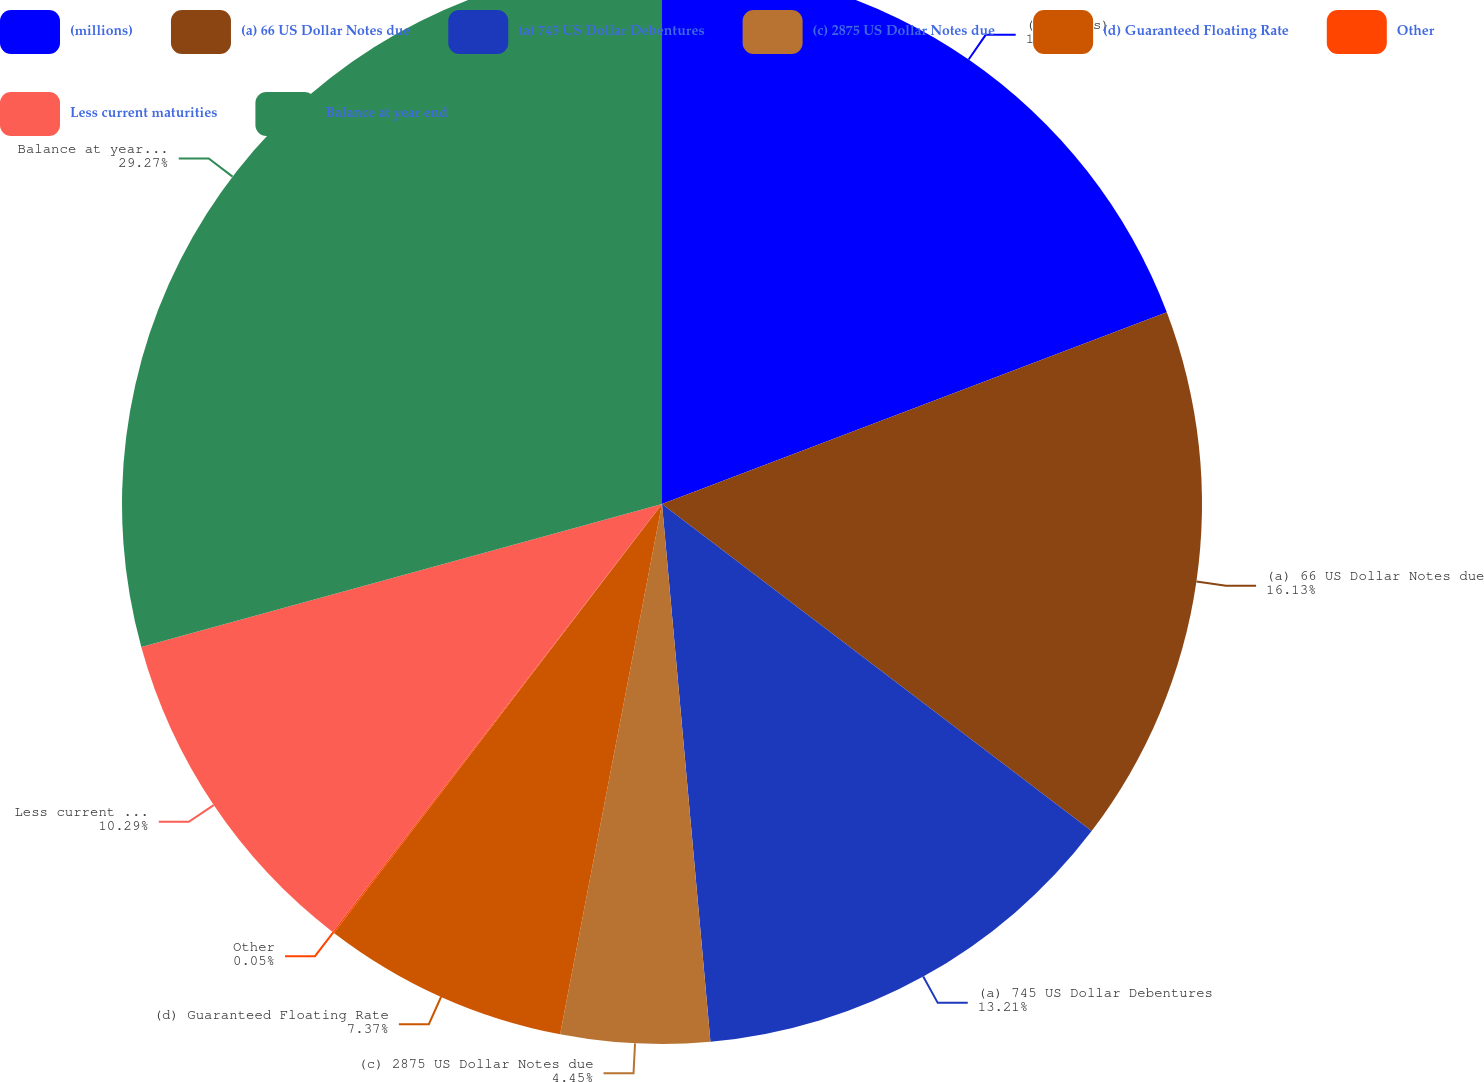Convert chart. <chart><loc_0><loc_0><loc_500><loc_500><pie_chart><fcel>(millions)<fcel>(a) 66 US Dollar Notes due<fcel>(a) 745 US Dollar Debentures<fcel>(c) 2875 US Dollar Notes due<fcel>(d) Guaranteed Floating Rate<fcel>Other<fcel>Less current maturities<fcel>Balance at year end<nl><fcel>19.22%<fcel>16.13%<fcel>13.21%<fcel>4.45%<fcel>7.37%<fcel>0.05%<fcel>10.29%<fcel>29.26%<nl></chart> 